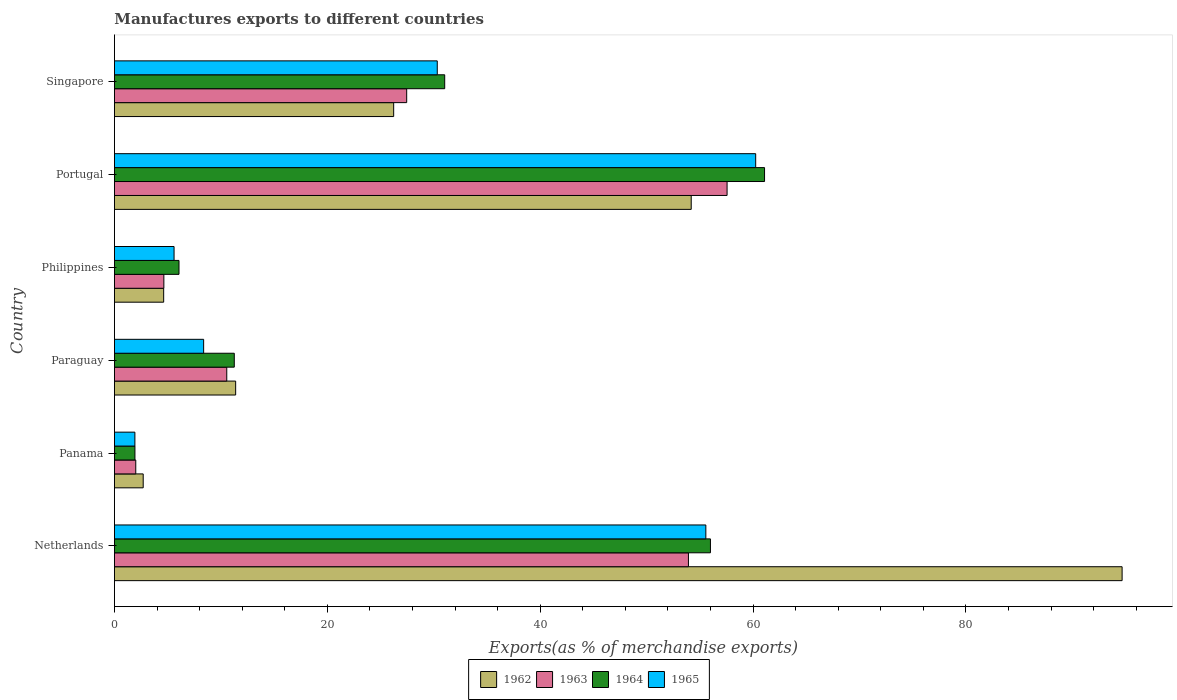How many different coloured bars are there?
Your answer should be compact. 4. How many groups of bars are there?
Your answer should be very brief. 6. Are the number of bars on each tick of the Y-axis equal?
Make the answer very short. Yes. How many bars are there on the 6th tick from the top?
Offer a terse response. 4. How many bars are there on the 5th tick from the bottom?
Offer a terse response. 4. What is the label of the 1st group of bars from the top?
Provide a short and direct response. Singapore. In how many cases, is the number of bars for a given country not equal to the number of legend labels?
Offer a terse response. 0. What is the percentage of exports to different countries in 1963 in Netherlands?
Give a very brief answer. 53.93. Across all countries, what is the maximum percentage of exports to different countries in 1962?
Offer a very short reply. 94.68. Across all countries, what is the minimum percentage of exports to different countries in 1963?
Your answer should be very brief. 2. In which country was the percentage of exports to different countries in 1965 minimum?
Offer a very short reply. Panama. What is the total percentage of exports to different countries in 1964 in the graph?
Provide a succinct answer. 167.37. What is the difference between the percentage of exports to different countries in 1964 in Paraguay and that in Singapore?
Offer a terse response. -19.77. What is the difference between the percentage of exports to different countries in 1962 in Paraguay and the percentage of exports to different countries in 1963 in Singapore?
Keep it short and to the point. -16.07. What is the average percentage of exports to different countries in 1962 per country?
Offer a very short reply. 32.3. What is the difference between the percentage of exports to different countries in 1965 and percentage of exports to different countries in 1962 in Panama?
Give a very brief answer. -0.78. In how many countries, is the percentage of exports to different countries in 1965 greater than 44 %?
Give a very brief answer. 2. What is the ratio of the percentage of exports to different countries in 1964 in Netherlands to that in Panama?
Make the answer very short. 29.06. Is the difference between the percentage of exports to different countries in 1965 in Paraguay and Philippines greater than the difference between the percentage of exports to different countries in 1962 in Paraguay and Philippines?
Give a very brief answer. No. What is the difference between the highest and the second highest percentage of exports to different countries in 1965?
Your answer should be very brief. 4.68. What is the difference between the highest and the lowest percentage of exports to different countries in 1963?
Your answer should be very brief. 55.56. Is the sum of the percentage of exports to different countries in 1965 in Netherlands and Singapore greater than the maximum percentage of exports to different countries in 1963 across all countries?
Give a very brief answer. Yes. What does the 1st bar from the top in Panama represents?
Offer a terse response. 1965. How many bars are there?
Offer a terse response. 24. Are all the bars in the graph horizontal?
Provide a short and direct response. Yes. How many countries are there in the graph?
Keep it short and to the point. 6. What is the difference between two consecutive major ticks on the X-axis?
Offer a very short reply. 20. How many legend labels are there?
Offer a very short reply. 4. How are the legend labels stacked?
Make the answer very short. Horizontal. What is the title of the graph?
Ensure brevity in your answer.  Manufactures exports to different countries. What is the label or title of the X-axis?
Make the answer very short. Exports(as % of merchandise exports). What is the Exports(as % of merchandise exports) in 1962 in Netherlands?
Your answer should be very brief. 94.68. What is the Exports(as % of merchandise exports) in 1963 in Netherlands?
Provide a short and direct response. 53.93. What is the Exports(as % of merchandise exports) in 1964 in Netherlands?
Offer a terse response. 56. What is the Exports(as % of merchandise exports) of 1965 in Netherlands?
Your response must be concise. 55.57. What is the Exports(as % of merchandise exports) in 1962 in Panama?
Provide a succinct answer. 2.7. What is the Exports(as % of merchandise exports) in 1963 in Panama?
Provide a short and direct response. 2. What is the Exports(as % of merchandise exports) of 1964 in Panama?
Your answer should be compact. 1.93. What is the Exports(as % of merchandise exports) in 1965 in Panama?
Make the answer very short. 1.92. What is the Exports(as % of merchandise exports) in 1962 in Paraguay?
Make the answer very short. 11.39. What is the Exports(as % of merchandise exports) in 1963 in Paraguay?
Your answer should be very brief. 10.55. What is the Exports(as % of merchandise exports) of 1964 in Paraguay?
Offer a terse response. 11.26. What is the Exports(as % of merchandise exports) in 1965 in Paraguay?
Ensure brevity in your answer.  8.38. What is the Exports(as % of merchandise exports) of 1962 in Philippines?
Give a very brief answer. 4.63. What is the Exports(as % of merchandise exports) in 1963 in Philippines?
Give a very brief answer. 4.64. What is the Exports(as % of merchandise exports) of 1964 in Philippines?
Keep it short and to the point. 6.07. What is the Exports(as % of merchandise exports) of 1965 in Philippines?
Offer a terse response. 5.6. What is the Exports(as % of merchandise exports) in 1962 in Portugal?
Keep it short and to the point. 54.19. What is the Exports(as % of merchandise exports) of 1963 in Portugal?
Ensure brevity in your answer.  57.56. What is the Exports(as % of merchandise exports) in 1964 in Portugal?
Give a very brief answer. 61.08. What is the Exports(as % of merchandise exports) in 1965 in Portugal?
Offer a terse response. 60.25. What is the Exports(as % of merchandise exports) of 1962 in Singapore?
Provide a short and direct response. 26.24. What is the Exports(as % of merchandise exports) of 1963 in Singapore?
Your answer should be very brief. 27.46. What is the Exports(as % of merchandise exports) of 1964 in Singapore?
Your answer should be very brief. 31.03. What is the Exports(as % of merchandise exports) of 1965 in Singapore?
Provide a succinct answer. 30.33. Across all countries, what is the maximum Exports(as % of merchandise exports) in 1962?
Provide a succinct answer. 94.68. Across all countries, what is the maximum Exports(as % of merchandise exports) in 1963?
Give a very brief answer. 57.56. Across all countries, what is the maximum Exports(as % of merchandise exports) in 1964?
Keep it short and to the point. 61.08. Across all countries, what is the maximum Exports(as % of merchandise exports) in 1965?
Offer a very short reply. 60.25. Across all countries, what is the minimum Exports(as % of merchandise exports) of 1962?
Provide a short and direct response. 2.7. Across all countries, what is the minimum Exports(as % of merchandise exports) in 1963?
Offer a very short reply. 2. Across all countries, what is the minimum Exports(as % of merchandise exports) of 1964?
Your answer should be very brief. 1.93. Across all countries, what is the minimum Exports(as % of merchandise exports) in 1965?
Give a very brief answer. 1.92. What is the total Exports(as % of merchandise exports) of 1962 in the graph?
Keep it short and to the point. 193.83. What is the total Exports(as % of merchandise exports) of 1963 in the graph?
Your response must be concise. 156.16. What is the total Exports(as % of merchandise exports) of 1964 in the graph?
Give a very brief answer. 167.37. What is the total Exports(as % of merchandise exports) of 1965 in the graph?
Your response must be concise. 162.06. What is the difference between the Exports(as % of merchandise exports) in 1962 in Netherlands and that in Panama?
Offer a very short reply. 91.97. What is the difference between the Exports(as % of merchandise exports) in 1963 in Netherlands and that in Panama?
Provide a succinct answer. 51.93. What is the difference between the Exports(as % of merchandise exports) of 1964 in Netherlands and that in Panama?
Your answer should be compact. 54.07. What is the difference between the Exports(as % of merchandise exports) of 1965 in Netherlands and that in Panama?
Make the answer very short. 53.64. What is the difference between the Exports(as % of merchandise exports) of 1962 in Netherlands and that in Paraguay?
Your response must be concise. 83.29. What is the difference between the Exports(as % of merchandise exports) in 1963 in Netherlands and that in Paraguay?
Provide a short and direct response. 43.38. What is the difference between the Exports(as % of merchandise exports) of 1964 in Netherlands and that in Paraguay?
Offer a very short reply. 44.74. What is the difference between the Exports(as % of merchandise exports) of 1965 in Netherlands and that in Paraguay?
Ensure brevity in your answer.  47.19. What is the difference between the Exports(as % of merchandise exports) in 1962 in Netherlands and that in Philippines?
Keep it short and to the point. 90.05. What is the difference between the Exports(as % of merchandise exports) in 1963 in Netherlands and that in Philippines?
Your response must be concise. 49.29. What is the difference between the Exports(as % of merchandise exports) in 1964 in Netherlands and that in Philippines?
Your answer should be very brief. 49.93. What is the difference between the Exports(as % of merchandise exports) of 1965 in Netherlands and that in Philippines?
Provide a succinct answer. 49.96. What is the difference between the Exports(as % of merchandise exports) of 1962 in Netherlands and that in Portugal?
Provide a succinct answer. 40.48. What is the difference between the Exports(as % of merchandise exports) in 1963 in Netherlands and that in Portugal?
Make the answer very short. -3.63. What is the difference between the Exports(as % of merchandise exports) in 1964 in Netherlands and that in Portugal?
Provide a succinct answer. -5.08. What is the difference between the Exports(as % of merchandise exports) of 1965 in Netherlands and that in Portugal?
Your response must be concise. -4.68. What is the difference between the Exports(as % of merchandise exports) in 1962 in Netherlands and that in Singapore?
Keep it short and to the point. 68.44. What is the difference between the Exports(as % of merchandise exports) of 1963 in Netherlands and that in Singapore?
Make the answer very short. 26.47. What is the difference between the Exports(as % of merchandise exports) of 1964 in Netherlands and that in Singapore?
Your answer should be compact. 24.97. What is the difference between the Exports(as % of merchandise exports) of 1965 in Netherlands and that in Singapore?
Ensure brevity in your answer.  25.23. What is the difference between the Exports(as % of merchandise exports) of 1962 in Panama and that in Paraguay?
Make the answer very short. -8.69. What is the difference between the Exports(as % of merchandise exports) in 1963 in Panama and that in Paraguay?
Your answer should be compact. -8.55. What is the difference between the Exports(as % of merchandise exports) of 1964 in Panama and that in Paraguay?
Ensure brevity in your answer.  -9.33. What is the difference between the Exports(as % of merchandise exports) in 1965 in Panama and that in Paraguay?
Keep it short and to the point. -6.46. What is the difference between the Exports(as % of merchandise exports) in 1962 in Panama and that in Philippines?
Offer a very short reply. -1.92. What is the difference between the Exports(as % of merchandise exports) of 1963 in Panama and that in Philippines?
Provide a short and direct response. -2.64. What is the difference between the Exports(as % of merchandise exports) of 1964 in Panama and that in Philippines?
Make the answer very short. -4.14. What is the difference between the Exports(as % of merchandise exports) of 1965 in Panama and that in Philippines?
Your answer should be compact. -3.68. What is the difference between the Exports(as % of merchandise exports) of 1962 in Panama and that in Portugal?
Ensure brevity in your answer.  -51.49. What is the difference between the Exports(as % of merchandise exports) in 1963 in Panama and that in Portugal?
Your answer should be compact. -55.56. What is the difference between the Exports(as % of merchandise exports) of 1964 in Panama and that in Portugal?
Provide a short and direct response. -59.16. What is the difference between the Exports(as % of merchandise exports) in 1965 in Panama and that in Portugal?
Give a very brief answer. -58.33. What is the difference between the Exports(as % of merchandise exports) in 1962 in Panama and that in Singapore?
Your answer should be very brief. -23.53. What is the difference between the Exports(as % of merchandise exports) in 1963 in Panama and that in Singapore?
Keep it short and to the point. -25.46. What is the difference between the Exports(as % of merchandise exports) of 1964 in Panama and that in Singapore?
Offer a terse response. -29.1. What is the difference between the Exports(as % of merchandise exports) in 1965 in Panama and that in Singapore?
Your answer should be compact. -28.41. What is the difference between the Exports(as % of merchandise exports) in 1962 in Paraguay and that in Philippines?
Make the answer very short. 6.76. What is the difference between the Exports(as % of merchandise exports) in 1963 in Paraguay and that in Philippines?
Your response must be concise. 5.91. What is the difference between the Exports(as % of merchandise exports) in 1964 in Paraguay and that in Philippines?
Give a very brief answer. 5.19. What is the difference between the Exports(as % of merchandise exports) of 1965 in Paraguay and that in Philippines?
Provide a short and direct response. 2.78. What is the difference between the Exports(as % of merchandise exports) in 1962 in Paraguay and that in Portugal?
Provide a short and direct response. -42.8. What is the difference between the Exports(as % of merchandise exports) of 1963 in Paraguay and that in Portugal?
Provide a succinct answer. -47.01. What is the difference between the Exports(as % of merchandise exports) in 1964 in Paraguay and that in Portugal?
Provide a short and direct response. -49.82. What is the difference between the Exports(as % of merchandise exports) in 1965 in Paraguay and that in Portugal?
Provide a short and direct response. -51.87. What is the difference between the Exports(as % of merchandise exports) in 1962 in Paraguay and that in Singapore?
Make the answer very short. -14.85. What is the difference between the Exports(as % of merchandise exports) of 1963 in Paraguay and that in Singapore?
Provide a succinct answer. -16.91. What is the difference between the Exports(as % of merchandise exports) in 1964 in Paraguay and that in Singapore?
Make the answer very short. -19.77. What is the difference between the Exports(as % of merchandise exports) of 1965 in Paraguay and that in Singapore?
Offer a terse response. -21.95. What is the difference between the Exports(as % of merchandise exports) in 1962 in Philippines and that in Portugal?
Offer a terse response. -49.57. What is the difference between the Exports(as % of merchandise exports) in 1963 in Philippines and that in Portugal?
Provide a succinct answer. -52.92. What is the difference between the Exports(as % of merchandise exports) in 1964 in Philippines and that in Portugal?
Your answer should be compact. -55.02. What is the difference between the Exports(as % of merchandise exports) in 1965 in Philippines and that in Portugal?
Ensure brevity in your answer.  -54.65. What is the difference between the Exports(as % of merchandise exports) in 1962 in Philippines and that in Singapore?
Provide a short and direct response. -21.61. What is the difference between the Exports(as % of merchandise exports) of 1963 in Philippines and that in Singapore?
Offer a terse response. -22.82. What is the difference between the Exports(as % of merchandise exports) of 1964 in Philippines and that in Singapore?
Give a very brief answer. -24.96. What is the difference between the Exports(as % of merchandise exports) in 1965 in Philippines and that in Singapore?
Offer a terse response. -24.73. What is the difference between the Exports(as % of merchandise exports) in 1962 in Portugal and that in Singapore?
Your answer should be very brief. 27.96. What is the difference between the Exports(as % of merchandise exports) of 1963 in Portugal and that in Singapore?
Your response must be concise. 30.1. What is the difference between the Exports(as % of merchandise exports) of 1964 in Portugal and that in Singapore?
Give a very brief answer. 30.05. What is the difference between the Exports(as % of merchandise exports) of 1965 in Portugal and that in Singapore?
Provide a succinct answer. 29.92. What is the difference between the Exports(as % of merchandise exports) of 1962 in Netherlands and the Exports(as % of merchandise exports) of 1963 in Panama?
Your answer should be very brief. 92.67. What is the difference between the Exports(as % of merchandise exports) of 1962 in Netherlands and the Exports(as % of merchandise exports) of 1964 in Panama?
Keep it short and to the point. 92.75. What is the difference between the Exports(as % of merchandise exports) of 1962 in Netherlands and the Exports(as % of merchandise exports) of 1965 in Panama?
Give a very brief answer. 92.75. What is the difference between the Exports(as % of merchandise exports) of 1963 in Netherlands and the Exports(as % of merchandise exports) of 1964 in Panama?
Your response must be concise. 52. What is the difference between the Exports(as % of merchandise exports) in 1963 in Netherlands and the Exports(as % of merchandise exports) in 1965 in Panama?
Offer a very short reply. 52.01. What is the difference between the Exports(as % of merchandise exports) in 1964 in Netherlands and the Exports(as % of merchandise exports) in 1965 in Panama?
Keep it short and to the point. 54.07. What is the difference between the Exports(as % of merchandise exports) of 1962 in Netherlands and the Exports(as % of merchandise exports) of 1963 in Paraguay?
Your answer should be very brief. 84.12. What is the difference between the Exports(as % of merchandise exports) of 1962 in Netherlands and the Exports(as % of merchandise exports) of 1964 in Paraguay?
Provide a short and direct response. 83.42. What is the difference between the Exports(as % of merchandise exports) in 1962 in Netherlands and the Exports(as % of merchandise exports) in 1965 in Paraguay?
Offer a very short reply. 86.3. What is the difference between the Exports(as % of merchandise exports) in 1963 in Netherlands and the Exports(as % of merchandise exports) in 1964 in Paraguay?
Your answer should be compact. 42.67. What is the difference between the Exports(as % of merchandise exports) in 1963 in Netherlands and the Exports(as % of merchandise exports) in 1965 in Paraguay?
Offer a very short reply. 45.55. What is the difference between the Exports(as % of merchandise exports) in 1964 in Netherlands and the Exports(as % of merchandise exports) in 1965 in Paraguay?
Give a very brief answer. 47.62. What is the difference between the Exports(as % of merchandise exports) in 1962 in Netherlands and the Exports(as % of merchandise exports) in 1963 in Philippines?
Offer a very short reply. 90.03. What is the difference between the Exports(as % of merchandise exports) in 1962 in Netherlands and the Exports(as % of merchandise exports) in 1964 in Philippines?
Your response must be concise. 88.61. What is the difference between the Exports(as % of merchandise exports) in 1962 in Netherlands and the Exports(as % of merchandise exports) in 1965 in Philippines?
Make the answer very short. 89.07. What is the difference between the Exports(as % of merchandise exports) of 1963 in Netherlands and the Exports(as % of merchandise exports) of 1964 in Philippines?
Offer a very short reply. 47.86. What is the difference between the Exports(as % of merchandise exports) in 1963 in Netherlands and the Exports(as % of merchandise exports) in 1965 in Philippines?
Make the answer very short. 48.33. What is the difference between the Exports(as % of merchandise exports) of 1964 in Netherlands and the Exports(as % of merchandise exports) of 1965 in Philippines?
Your response must be concise. 50.4. What is the difference between the Exports(as % of merchandise exports) in 1962 in Netherlands and the Exports(as % of merchandise exports) in 1963 in Portugal?
Keep it short and to the point. 37.12. What is the difference between the Exports(as % of merchandise exports) of 1962 in Netherlands and the Exports(as % of merchandise exports) of 1964 in Portugal?
Your answer should be compact. 33.59. What is the difference between the Exports(as % of merchandise exports) in 1962 in Netherlands and the Exports(as % of merchandise exports) in 1965 in Portugal?
Your answer should be compact. 34.43. What is the difference between the Exports(as % of merchandise exports) of 1963 in Netherlands and the Exports(as % of merchandise exports) of 1964 in Portugal?
Offer a terse response. -7.15. What is the difference between the Exports(as % of merchandise exports) in 1963 in Netherlands and the Exports(as % of merchandise exports) in 1965 in Portugal?
Your answer should be compact. -6.32. What is the difference between the Exports(as % of merchandise exports) of 1964 in Netherlands and the Exports(as % of merchandise exports) of 1965 in Portugal?
Offer a terse response. -4.25. What is the difference between the Exports(as % of merchandise exports) in 1962 in Netherlands and the Exports(as % of merchandise exports) in 1963 in Singapore?
Give a very brief answer. 67.22. What is the difference between the Exports(as % of merchandise exports) in 1962 in Netherlands and the Exports(as % of merchandise exports) in 1964 in Singapore?
Keep it short and to the point. 63.65. What is the difference between the Exports(as % of merchandise exports) of 1962 in Netherlands and the Exports(as % of merchandise exports) of 1965 in Singapore?
Provide a short and direct response. 64.34. What is the difference between the Exports(as % of merchandise exports) of 1963 in Netherlands and the Exports(as % of merchandise exports) of 1964 in Singapore?
Provide a short and direct response. 22.9. What is the difference between the Exports(as % of merchandise exports) of 1963 in Netherlands and the Exports(as % of merchandise exports) of 1965 in Singapore?
Give a very brief answer. 23.6. What is the difference between the Exports(as % of merchandise exports) in 1964 in Netherlands and the Exports(as % of merchandise exports) in 1965 in Singapore?
Offer a very short reply. 25.67. What is the difference between the Exports(as % of merchandise exports) in 1962 in Panama and the Exports(as % of merchandise exports) in 1963 in Paraguay?
Your response must be concise. -7.85. What is the difference between the Exports(as % of merchandise exports) in 1962 in Panama and the Exports(as % of merchandise exports) in 1964 in Paraguay?
Your response must be concise. -8.56. What is the difference between the Exports(as % of merchandise exports) of 1962 in Panama and the Exports(as % of merchandise exports) of 1965 in Paraguay?
Your answer should be very brief. -5.68. What is the difference between the Exports(as % of merchandise exports) in 1963 in Panama and the Exports(as % of merchandise exports) in 1964 in Paraguay?
Provide a succinct answer. -9.26. What is the difference between the Exports(as % of merchandise exports) of 1963 in Panama and the Exports(as % of merchandise exports) of 1965 in Paraguay?
Offer a very short reply. -6.38. What is the difference between the Exports(as % of merchandise exports) in 1964 in Panama and the Exports(as % of merchandise exports) in 1965 in Paraguay?
Make the answer very short. -6.45. What is the difference between the Exports(as % of merchandise exports) in 1962 in Panama and the Exports(as % of merchandise exports) in 1963 in Philippines?
Your answer should be very brief. -1.94. What is the difference between the Exports(as % of merchandise exports) in 1962 in Panama and the Exports(as % of merchandise exports) in 1964 in Philippines?
Your answer should be compact. -3.36. What is the difference between the Exports(as % of merchandise exports) of 1962 in Panama and the Exports(as % of merchandise exports) of 1965 in Philippines?
Keep it short and to the point. -2.9. What is the difference between the Exports(as % of merchandise exports) in 1963 in Panama and the Exports(as % of merchandise exports) in 1964 in Philippines?
Keep it short and to the point. -4.06. What is the difference between the Exports(as % of merchandise exports) of 1963 in Panama and the Exports(as % of merchandise exports) of 1965 in Philippines?
Make the answer very short. -3.6. What is the difference between the Exports(as % of merchandise exports) in 1964 in Panama and the Exports(as % of merchandise exports) in 1965 in Philippines?
Your answer should be compact. -3.68. What is the difference between the Exports(as % of merchandise exports) of 1962 in Panama and the Exports(as % of merchandise exports) of 1963 in Portugal?
Your response must be concise. -54.86. What is the difference between the Exports(as % of merchandise exports) in 1962 in Panama and the Exports(as % of merchandise exports) in 1964 in Portugal?
Offer a terse response. -58.38. What is the difference between the Exports(as % of merchandise exports) in 1962 in Panama and the Exports(as % of merchandise exports) in 1965 in Portugal?
Give a very brief answer. -57.55. What is the difference between the Exports(as % of merchandise exports) in 1963 in Panama and the Exports(as % of merchandise exports) in 1964 in Portugal?
Provide a short and direct response. -59.08. What is the difference between the Exports(as % of merchandise exports) of 1963 in Panama and the Exports(as % of merchandise exports) of 1965 in Portugal?
Keep it short and to the point. -58.25. What is the difference between the Exports(as % of merchandise exports) in 1964 in Panama and the Exports(as % of merchandise exports) in 1965 in Portugal?
Your answer should be compact. -58.32. What is the difference between the Exports(as % of merchandise exports) of 1962 in Panama and the Exports(as % of merchandise exports) of 1963 in Singapore?
Provide a succinct answer. -24.76. What is the difference between the Exports(as % of merchandise exports) in 1962 in Panama and the Exports(as % of merchandise exports) in 1964 in Singapore?
Offer a very short reply. -28.33. What is the difference between the Exports(as % of merchandise exports) of 1962 in Panama and the Exports(as % of merchandise exports) of 1965 in Singapore?
Make the answer very short. -27.63. What is the difference between the Exports(as % of merchandise exports) in 1963 in Panama and the Exports(as % of merchandise exports) in 1964 in Singapore?
Ensure brevity in your answer.  -29.03. What is the difference between the Exports(as % of merchandise exports) of 1963 in Panama and the Exports(as % of merchandise exports) of 1965 in Singapore?
Provide a succinct answer. -28.33. What is the difference between the Exports(as % of merchandise exports) in 1964 in Panama and the Exports(as % of merchandise exports) in 1965 in Singapore?
Provide a succinct answer. -28.41. What is the difference between the Exports(as % of merchandise exports) in 1962 in Paraguay and the Exports(as % of merchandise exports) in 1963 in Philippines?
Ensure brevity in your answer.  6.75. What is the difference between the Exports(as % of merchandise exports) in 1962 in Paraguay and the Exports(as % of merchandise exports) in 1964 in Philippines?
Your response must be concise. 5.32. What is the difference between the Exports(as % of merchandise exports) of 1962 in Paraguay and the Exports(as % of merchandise exports) of 1965 in Philippines?
Your answer should be compact. 5.79. What is the difference between the Exports(as % of merchandise exports) in 1963 in Paraguay and the Exports(as % of merchandise exports) in 1964 in Philippines?
Provide a short and direct response. 4.49. What is the difference between the Exports(as % of merchandise exports) of 1963 in Paraguay and the Exports(as % of merchandise exports) of 1965 in Philippines?
Provide a short and direct response. 4.95. What is the difference between the Exports(as % of merchandise exports) in 1964 in Paraguay and the Exports(as % of merchandise exports) in 1965 in Philippines?
Provide a succinct answer. 5.66. What is the difference between the Exports(as % of merchandise exports) in 1962 in Paraguay and the Exports(as % of merchandise exports) in 1963 in Portugal?
Offer a terse response. -46.17. What is the difference between the Exports(as % of merchandise exports) of 1962 in Paraguay and the Exports(as % of merchandise exports) of 1964 in Portugal?
Provide a succinct answer. -49.69. What is the difference between the Exports(as % of merchandise exports) in 1962 in Paraguay and the Exports(as % of merchandise exports) in 1965 in Portugal?
Offer a very short reply. -48.86. What is the difference between the Exports(as % of merchandise exports) in 1963 in Paraguay and the Exports(as % of merchandise exports) in 1964 in Portugal?
Offer a terse response. -50.53. What is the difference between the Exports(as % of merchandise exports) of 1963 in Paraguay and the Exports(as % of merchandise exports) of 1965 in Portugal?
Provide a short and direct response. -49.7. What is the difference between the Exports(as % of merchandise exports) in 1964 in Paraguay and the Exports(as % of merchandise exports) in 1965 in Portugal?
Keep it short and to the point. -48.99. What is the difference between the Exports(as % of merchandise exports) in 1962 in Paraguay and the Exports(as % of merchandise exports) in 1963 in Singapore?
Provide a succinct answer. -16.07. What is the difference between the Exports(as % of merchandise exports) in 1962 in Paraguay and the Exports(as % of merchandise exports) in 1964 in Singapore?
Provide a short and direct response. -19.64. What is the difference between the Exports(as % of merchandise exports) in 1962 in Paraguay and the Exports(as % of merchandise exports) in 1965 in Singapore?
Make the answer very short. -18.94. What is the difference between the Exports(as % of merchandise exports) of 1963 in Paraguay and the Exports(as % of merchandise exports) of 1964 in Singapore?
Your response must be concise. -20.48. What is the difference between the Exports(as % of merchandise exports) in 1963 in Paraguay and the Exports(as % of merchandise exports) in 1965 in Singapore?
Give a very brief answer. -19.78. What is the difference between the Exports(as % of merchandise exports) in 1964 in Paraguay and the Exports(as % of merchandise exports) in 1965 in Singapore?
Give a very brief answer. -19.07. What is the difference between the Exports(as % of merchandise exports) of 1962 in Philippines and the Exports(as % of merchandise exports) of 1963 in Portugal?
Keep it short and to the point. -52.93. What is the difference between the Exports(as % of merchandise exports) in 1962 in Philippines and the Exports(as % of merchandise exports) in 1964 in Portugal?
Provide a short and direct response. -56.46. What is the difference between the Exports(as % of merchandise exports) in 1962 in Philippines and the Exports(as % of merchandise exports) in 1965 in Portugal?
Provide a short and direct response. -55.62. What is the difference between the Exports(as % of merchandise exports) of 1963 in Philippines and the Exports(as % of merchandise exports) of 1964 in Portugal?
Make the answer very short. -56.44. What is the difference between the Exports(as % of merchandise exports) in 1963 in Philippines and the Exports(as % of merchandise exports) in 1965 in Portugal?
Ensure brevity in your answer.  -55.61. What is the difference between the Exports(as % of merchandise exports) of 1964 in Philippines and the Exports(as % of merchandise exports) of 1965 in Portugal?
Offer a terse response. -54.18. What is the difference between the Exports(as % of merchandise exports) in 1962 in Philippines and the Exports(as % of merchandise exports) in 1963 in Singapore?
Ensure brevity in your answer.  -22.83. What is the difference between the Exports(as % of merchandise exports) in 1962 in Philippines and the Exports(as % of merchandise exports) in 1964 in Singapore?
Offer a very short reply. -26.4. What is the difference between the Exports(as % of merchandise exports) in 1962 in Philippines and the Exports(as % of merchandise exports) in 1965 in Singapore?
Your answer should be very brief. -25.7. What is the difference between the Exports(as % of merchandise exports) in 1963 in Philippines and the Exports(as % of merchandise exports) in 1964 in Singapore?
Your answer should be very brief. -26.39. What is the difference between the Exports(as % of merchandise exports) of 1963 in Philippines and the Exports(as % of merchandise exports) of 1965 in Singapore?
Your answer should be very brief. -25.69. What is the difference between the Exports(as % of merchandise exports) of 1964 in Philippines and the Exports(as % of merchandise exports) of 1965 in Singapore?
Your answer should be very brief. -24.27. What is the difference between the Exports(as % of merchandise exports) in 1962 in Portugal and the Exports(as % of merchandise exports) in 1963 in Singapore?
Ensure brevity in your answer.  26.73. What is the difference between the Exports(as % of merchandise exports) in 1962 in Portugal and the Exports(as % of merchandise exports) in 1964 in Singapore?
Keep it short and to the point. 23.16. What is the difference between the Exports(as % of merchandise exports) of 1962 in Portugal and the Exports(as % of merchandise exports) of 1965 in Singapore?
Your answer should be compact. 23.86. What is the difference between the Exports(as % of merchandise exports) of 1963 in Portugal and the Exports(as % of merchandise exports) of 1964 in Singapore?
Keep it short and to the point. 26.53. What is the difference between the Exports(as % of merchandise exports) of 1963 in Portugal and the Exports(as % of merchandise exports) of 1965 in Singapore?
Give a very brief answer. 27.23. What is the difference between the Exports(as % of merchandise exports) in 1964 in Portugal and the Exports(as % of merchandise exports) in 1965 in Singapore?
Keep it short and to the point. 30.75. What is the average Exports(as % of merchandise exports) in 1962 per country?
Offer a very short reply. 32.3. What is the average Exports(as % of merchandise exports) in 1963 per country?
Provide a succinct answer. 26.03. What is the average Exports(as % of merchandise exports) in 1964 per country?
Offer a terse response. 27.89. What is the average Exports(as % of merchandise exports) of 1965 per country?
Your answer should be compact. 27.01. What is the difference between the Exports(as % of merchandise exports) of 1962 and Exports(as % of merchandise exports) of 1963 in Netherlands?
Offer a terse response. 40.75. What is the difference between the Exports(as % of merchandise exports) of 1962 and Exports(as % of merchandise exports) of 1964 in Netherlands?
Offer a terse response. 38.68. What is the difference between the Exports(as % of merchandise exports) of 1962 and Exports(as % of merchandise exports) of 1965 in Netherlands?
Provide a short and direct response. 39.11. What is the difference between the Exports(as % of merchandise exports) in 1963 and Exports(as % of merchandise exports) in 1964 in Netherlands?
Your answer should be compact. -2.07. What is the difference between the Exports(as % of merchandise exports) of 1963 and Exports(as % of merchandise exports) of 1965 in Netherlands?
Ensure brevity in your answer.  -1.64. What is the difference between the Exports(as % of merchandise exports) in 1964 and Exports(as % of merchandise exports) in 1965 in Netherlands?
Offer a very short reply. 0.43. What is the difference between the Exports(as % of merchandise exports) of 1962 and Exports(as % of merchandise exports) of 1963 in Panama?
Provide a succinct answer. 0.7. What is the difference between the Exports(as % of merchandise exports) of 1962 and Exports(as % of merchandise exports) of 1964 in Panama?
Make the answer very short. 0.78. What is the difference between the Exports(as % of merchandise exports) in 1962 and Exports(as % of merchandise exports) in 1965 in Panama?
Provide a succinct answer. 0.78. What is the difference between the Exports(as % of merchandise exports) of 1963 and Exports(as % of merchandise exports) of 1964 in Panama?
Provide a succinct answer. 0.08. What is the difference between the Exports(as % of merchandise exports) in 1963 and Exports(as % of merchandise exports) in 1965 in Panama?
Your response must be concise. 0.08. What is the difference between the Exports(as % of merchandise exports) of 1964 and Exports(as % of merchandise exports) of 1965 in Panama?
Your response must be concise. 0. What is the difference between the Exports(as % of merchandise exports) in 1962 and Exports(as % of merchandise exports) in 1963 in Paraguay?
Your answer should be compact. 0.83. What is the difference between the Exports(as % of merchandise exports) of 1962 and Exports(as % of merchandise exports) of 1964 in Paraguay?
Ensure brevity in your answer.  0.13. What is the difference between the Exports(as % of merchandise exports) of 1962 and Exports(as % of merchandise exports) of 1965 in Paraguay?
Make the answer very short. 3.01. What is the difference between the Exports(as % of merchandise exports) of 1963 and Exports(as % of merchandise exports) of 1964 in Paraguay?
Make the answer very short. -0.71. What is the difference between the Exports(as % of merchandise exports) of 1963 and Exports(as % of merchandise exports) of 1965 in Paraguay?
Keep it short and to the point. 2.17. What is the difference between the Exports(as % of merchandise exports) of 1964 and Exports(as % of merchandise exports) of 1965 in Paraguay?
Offer a terse response. 2.88. What is the difference between the Exports(as % of merchandise exports) of 1962 and Exports(as % of merchandise exports) of 1963 in Philippines?
Ensure brevity in your answer.  -0.02. What is the difference between the Exports(as % of merchandise exports) of 1962 and Exports(as % of merchandise exports) of 1964 in Philippines?
Keep it short and to the point. -1.44. What is the difference between the Exports(as % of merchandise exports) in 1962 and Exports(as % of merchandise exports) in 1965 in Philippines?
Provide a short and direct response. -0.98. What is the difference between the Exports(as % of merchandise exports) in 1963 and Exports(as % of merchandise exports) in 1964 in Philippines?
Your answer should be very brief. -1.42. What is the difference between the Exports(as % of merchandise exports) in 1963 and Exports(as % of merchandise exports) in 1965 in Philippines?
Offer a terse response. -0.96. What is the difference between the Exports(as % of merchandise exports) of 1964 and Exports(as % of merchandise exports) of 1965 in Philippines?
Your answer should be compact. 0.46. What is the difference between the Exports(as % of merchandise exports) of 1962 and Exports(as % of merchandise exports) of 1963 in Portugal?
Ensure brevity in your answer.  -3.37. What is the difference between the Exports(as % of merchandise exports) in 1962 and Exports(as % of merchandise exports) in 1964 in Portugal?
Ensure brevity in your answer.  -6.89. What is the difference between the Exports(as % of merchandise exports) of 1962 and Exports(as % of merchandise exports) of 1965 in Portugal?
Your answer should be compact. -6.06. What is the difference between the Exports(as % of merchandise exports) in 1963 and Exports(as % of merchandise exports) in 1964 in Portugal?
Offer a very short reply. -3.52. What is the difference between the Exports(as % of merchandise exports) of 1963 and Exports(as % of merchandise exports) of 1965 in Portugal?
Offer a very short reply. -2.69. What is the difference between the Exports(as % of merchandise exports) in 1964 and Exports(as % of merchandise exports) in 1965 in Portugal?
Your answer should be compact. 0.83. What is the difference between the Exports(as % of merchandise exports) of 1962 and Exports(as % of merchandise exports) of 1963 in Singapore?
Your answer should be compact. -1.22. What is the difference between the Exports(as % of merchandise exports) in 1962 and Exports(as % of merchandise exports) in 1964 in Singapore?
Ensure brevity in your answer.  -4.79. What is the difference between the Exports(as % of merchandise exports) of 1962 and Exports(as % of merchandise exports) of 1965 in Singapore?
Provide a short and direct response. -4.1. What is the difference between the Exports(as % of merchandise exports) in 1963 and Exports(as % of merchandise exports) in 1964 in Singapore?
Give a very brief answer. -3.57. What is the difference between the Exports(as % of merchandise exports) in 1963 and Exports(as % of merchandise exports) in 1965 in Singapore?
Keep it short and to the point. -2.87. What is the difference between the Exports(as % of merchandise exports) of 1964 and Exports(as % of merchandise exports) of 1965 in Singapore?
Offer a terse response. 0.7. What is the ratio of the Exports(as % of merchandise exports) of 1962 in Netherlands to that in Panama?
Ensure brevity in your answer.  35.02. What is the ratio of the Exports(as % of merchandise exports) in 1963 in Netherlands to that in Panama?
Provide a succinct answer. 26.91. What is the ratio of the Exports(as % of merchandise exports) of 1964 in Netherlands to that in Panama?
Give a very brief answer. 29.06. What is the ratio of the Exports(as % of merchandise exports) in 1965 in Netherlands to that in Panama?
Make the answer very short. 28.9. What is the ratio of the Exports(as % of merchandise exports) in 1962 in Netherlands to that in Paraguay?
Provide a short and direct response. 8.31. What is the ratio of the Exports(as % of merchandise exports) of 1963 in Netherlands to that in Paraguay?
Your answer should be very brief. 5.11. What is the ratio of the Exports(as % of merchandise exports) in 1964 in Netherlands to that in Paraguay?
Your response must be concise. 4.97. What is the ratio of the Exports(as % of merchandise exports) in 1965 in Netherlands to that in Paraguay?
Your answer should be compact. 6.63. What is the ratio of the Exports(as % of merchandise exports) of 1962 in Netherlands to that in Philippines?
Ensure brevity in your answer.  20.46. What is the ratio of the Exports(as % of merchandise exports) of 1963 in Netherlands to that in Philippines?
Your response must be concise. 11.61. What is the ratio of the Exports(as % of merchandise exports) of 1964 in Netherlands to that in Philippines?
Your answer should be compact. 9.23. What is the ratio of the Exports(as % of merchandise exports) in 1965 in Netherlands to that in Philippines?
Keep it short and to the point. 9.92. What is the ratio of the Exports(as % of merchandise exports) in 1962 in Netherlands to that in Portugal?
Your answer should be very brief. 1.75. What is the ratio of the Exports(as % of merchandise exports) of 1963 in Netherlands to that in Portugal?
Your answer should be very brief. 0.94. What is the ratio of the Exports(as % of merchandise exports) in 1964 in Netherlands to that in Portugal?
Your response must be concise. 0.92. What is the ratio of the Exports(as % of merchandise exports) in 1965 in Netherlands to that in Portugal?
Your answer should be very brief. 0.92. What is the ratio of the Exports(as % of merchandise exports) of 1962 in Netherlands to that in Singapore?
Your response must be concise. 3.61. What is the ratio of the Exports(as % of merchandise exports) of 1963 in Netherlands to that in Singapore?
Your answer should be compact. 1.96. What is the ratio of the Exports(as % of merchandise exports) of 1964 in Netherlands to that in Singapore?
Provide a short and direct response. 1.8. What is the ratio of the Exports(as % of merchandise exports) in 1965 in Netherlands to that in Singapore?
Ensure brevity in your answer.  1.83. What is the ratio of the Exports(as % of merchandise exports) in 1962 in Panama to that in Paraguay?
Give a very brief answer. 0.24. What is the ratio of the Exports(as % of merchandise exports) of 1963 in Panama to that in Paraguay?
Offer a terse response. 0.19. What is the ratio of the Exports(as % of merchandise exports) of 1964 in Panama to that in Paraguay?
Your answer should be compact. 0.17. What is the ratio of the Exports(as % of merchandise exports) of 1965 in Panama to that in Paraguay?
Make the answer very short. 0.23. What is the ratio of the Exports(as % of merchandise exports) of 1962 in Panama to that in Philippines?
Provide a short and direct response. 0.58. What is the ratio of the Exports(as % of merchandise exports) in 1963 in Panama to that in Philippines?
Give a very brief answer. 0.43. What is the ratio of the Exports(as % of merchandise exports) of 1964 in Panama to that in Philippines?
Keep it short and to the point. 0.32. What is the ratio of the Exports(as % of merchandise exports) of 1965 in Panama to that in Philippines?
Offer a very short reply. 0.34. What is the ratio of the Exports(as % of merchandise exports) of 1962 in Panama to that in Portugal?
Provide a succinct answer. 0.05. What is the ratio of the Exports(as % of merchandise exports) of 1963 in Panama to that in Portugal?
Make the answer very short. 0.03. What is the ratio of the Exports(as % of merchandise exports) in 1964 in Panama to that in Portugal?
Ensure brevity in your answer.  0.03. What is the ratio of the Exports(as % of merchandise exports) of 1965 in Panama to that in Portugal?
Make the answer very short. 0.03. What is the ratio of the Exports(as % of merchandise exports) in 1962 in Panama to that in Singapore?
Provide a short and direct response. 0.1. What is the ratio of the Exports(as % of merchandise exports) in 1963 in Panama to that in Singapore?
Keep it short and to the point. 0.07. What is the ratio of the Exports(as % of merchandise exports) of 1964 in Panama to that in Singapore?
Your answer should be very brief. 0.06. What is the ratio of the Exports(as % of merchandise exports) in 1965 in Panama to that in Singapore?
Your response must be concise. 0.06. What is the ratio of the Exports(as % of merchandise exports) of 1962 in Paraguay to that in Philippines?
Your response must be concise. 2.46. What is the ratio of the Exports(as % of merchandise exports) of 1963 in Paraguay to that in Philippines?
Give a very brief answer. 2.27. What is the ratio of the Exports(as % of merchandise exports) in 1964 in Paraguay to that in Philippines?
Provide a short and direct response. 1.86. What is the ratio of the Exports(as % of merchandise exports) of 1965 in Paraguay to that in Philippines?
Keep it short and to the point. 1.5. What is the ratio of the Exports(as % of merchandise exports) of 1962 in Paraguay to that in Portugal?
Give a very brief answer. 0.21. What is the ratio of the Exports(as % of merchandise exports) of 1963 in Paraguay to that in Portugal?
Ensure brevity in your answer.  0.18. What is the ratio of the Exports(as % of merchandise exports) of 1964 in Paraguay to that in Portugal?
Offer a very short reply. 0.18. What is the ratio of the Exports(as % of merchandise exports) of 1965 in Paraguay to that in Portugal?
Ensure brevity in your answer.  0.14. What is the ratio of the Exports(as % of merchandise exports) in 1962 in Paraguay to that in Singapore?
Make the answer very short. 0.43. What is the ratio of the Exports(as % of merchandise exports) of 1963 in Paraguay to that in Singapore?
Provide a short and direct response. 0.38. What is the ratio of the Exports(as % of merchandise exports) in 1964 in Paraguay to that in Singapore?
Provide a short and direct response. 0.36. What is the ratio of the Exports(as % of merchandise exports) of 1965 in Paraguay to that in Singapore?
Your answer should be very brief. 0.28. What is the ratio of the Exports(as % of merchandise exports) in 1962 in Philippines to that in Portugal?
Keep it short and to the point. 0.09. What is the ratio of the Exports(as % of merchandise exports) in 1963 in Philippines to that in Portugal?
Your answer should be very brief. 0.08. What is the ratio of the Exports(as % of merchandise exports) of 1964 in Philippines to that in Portugal?
Make the answer very short. 0.1. What is the ratio of the Exports(as % of merchandise exports) in 1965 in Philippines to that in Portugal?
Give a very brief answer. 0.09. What is the ratio of the Exports(as % of merchandise exports) of 1962 in Philippines to that in Singapore?
Offer a terse response. 0.18. What is the ratio of the Exports(as % of merchandise exports) in 1963 in Philippines to that in Singapore?
Ensure brevity in your answer.  0.17. What is the ratio of the Exports(as % of merchandise exports) in 1964 in Philippines to that in Singapore?
Offer a very short reply. 0.2. What is the ratio of the Exports(as % of merchandise exports) of 1965 in Philippines to that in Singapore?
Keep it short and to the point. 0.18. What is the ratio of the Exports(as % of merchandise exports) of 1962 in Portugal to that in Singapore?
Keep it short and to the point. 2.07. What is the ratio of the Exports(as % of merchandise exports) of 1963 in Portugal to that in Singapore?
Make the answer very short. 2.1. What is the ratio of the Exports(as % of merchandise exports) of 1964 in Portugal to that in Singapore?
Offer a very short reply. 1.97. What is the ratio of the Exports(as % of merchandise exports) of 1965 in Portugal to that in Singapore?
Your answer should be compact. 1.99. What is the difference between the highest and the second highest Exports(as % of merchandise exports) of 1962?
Your answer should be very brief. 40.48. What is the difference between the highest and the second highest Exports(as % of merchandise exports) of 1963?
Your answer should be compact. 3.63. What is the difference between the highest and the second highest Exports(as % of merchandise exports) in 1964?
Your answer should be very brief. 5.08. What is the difference between the highest and the second highest Exports(as % of merchandise exports) in 1965?
Provide a short and direct response. 4.68. What is the difference between the highest and the lowest Exports(as % of merchandise exports) of 1962?
Your response must be concise. 91.97. What is the difference between the highest and the lowest Exports(as % of merchandise exports) of 1963?
Your answer should be compact. 55.56. What is the difference between the highest and the lowest Exports(as % of merchandise exports) of 1964?
Your response must be concise. 59.16. What is the difference between the highest and the lowest Exports(as % of merchandise exports) of 1965?
Your answer should be compact. 58.33. 